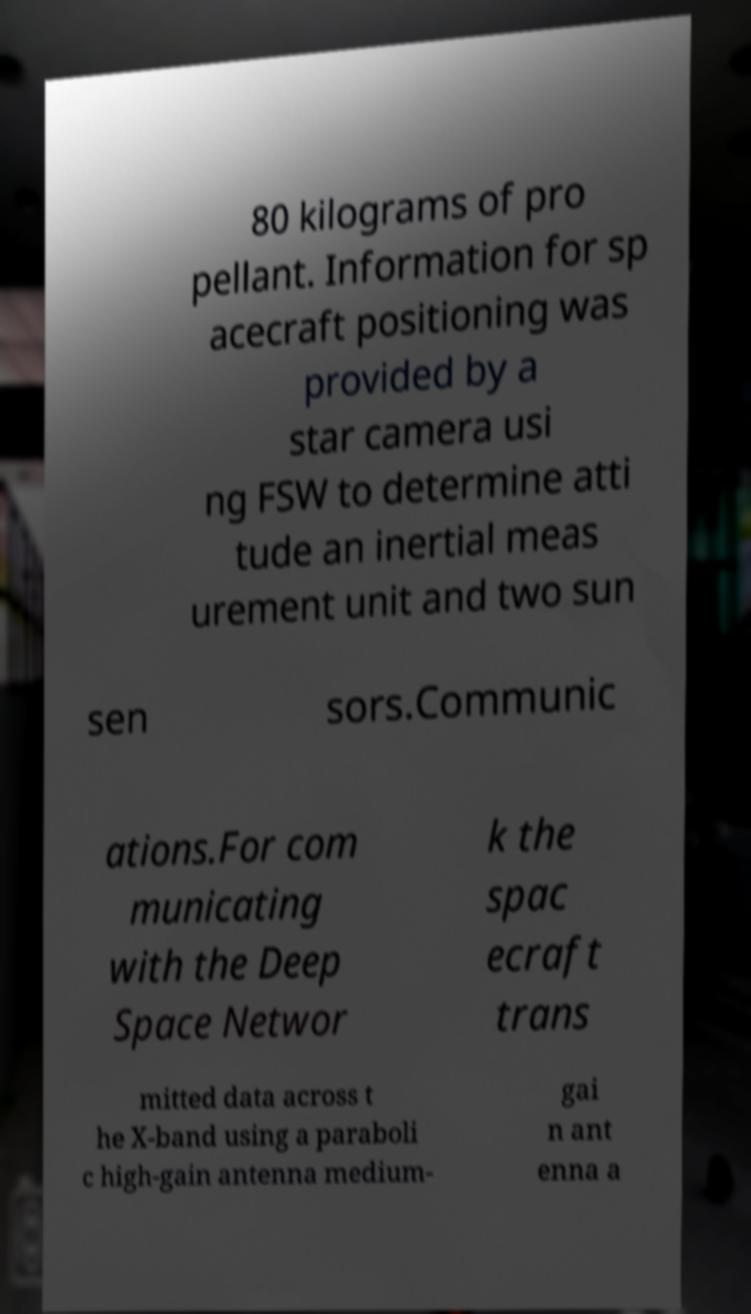Can you read and provide the text displayed in the image?This photo seems to have some interesting text. Can you extract and type it out for me? 80 kilograms of pro pellant. Information for sp acecraft positioning was provided by a star camera usi ng FSW to determine atti tude an inertial meas urement unit and two sun sen sors.Communic ations.For com municating with the Deep Space Networ k the spac ecraft trans mitted data across t he X-band using a paraboli c high-gain antenna medium- gai n ant enna a 